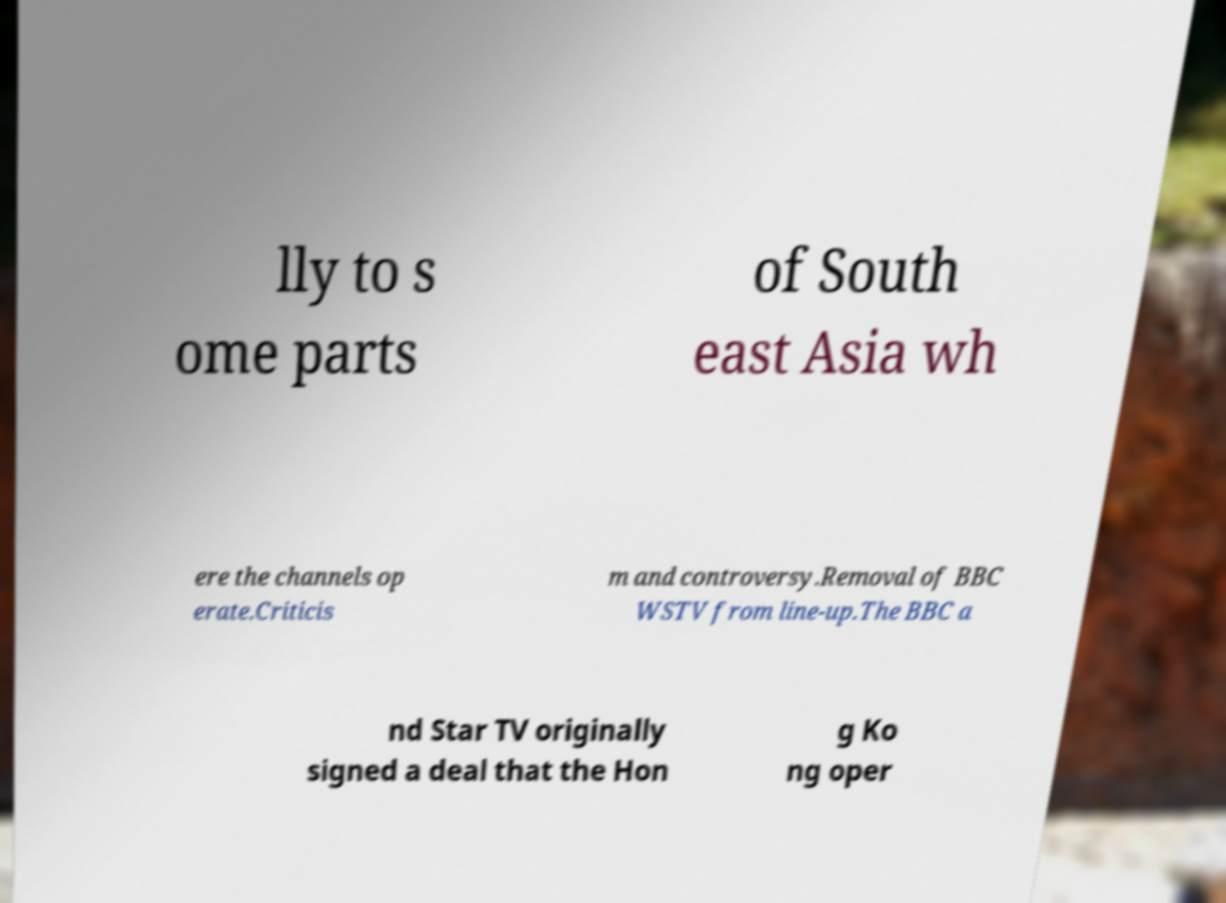There's text embedded in this image that I need extracted. Can you transcribe it verbatim? lly to s ome parts of South east Asia wh ere the channels op erate.Criticis m and controversy.Removal of BBC WSTV from line-up.The BBC a nd Star TV originally signed a deal that the Hon g Ko ng oper 